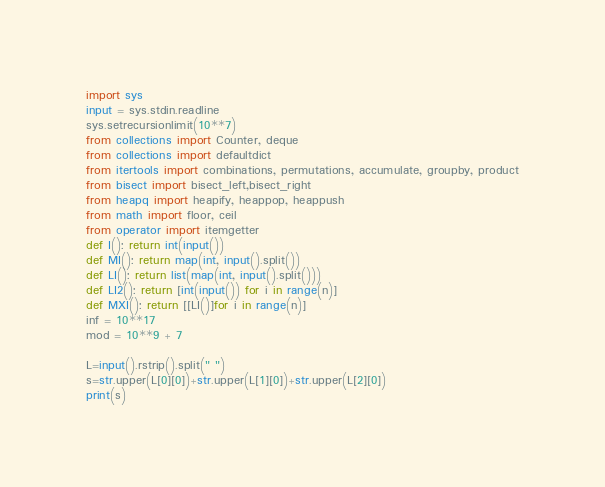<code> <loc_0><loc_0><loc_500><loc_500><_Python_>import sys
input = sys.stdin.readline
sys.setrecursionlimit(10**7)
from collections import Counter, deque
from collections import defaultdict
from itertools import combinations, permutations, accumulate, groupby, product
from bisect import bisect_left,bisect_right
from heapq import heapify, heappop, heappush
from math import floor, ceil
from operator import itemgetter
def I(): return int(input())
def MI(): return map(int, input().split())
def LI(): return list(map(int, input().split()))
def LI2(): return [int(input()) for i in range(n)]
def MXI(): return [[LI()]for i in range(n)]
inf = 10**17
mod = 10**9 + 7

L=input().rstrip().split(" ")
s=str.upper(L[0][0])+str.upper(L[1][0])+str.upper(L[2][0])
print(s)
</code> 